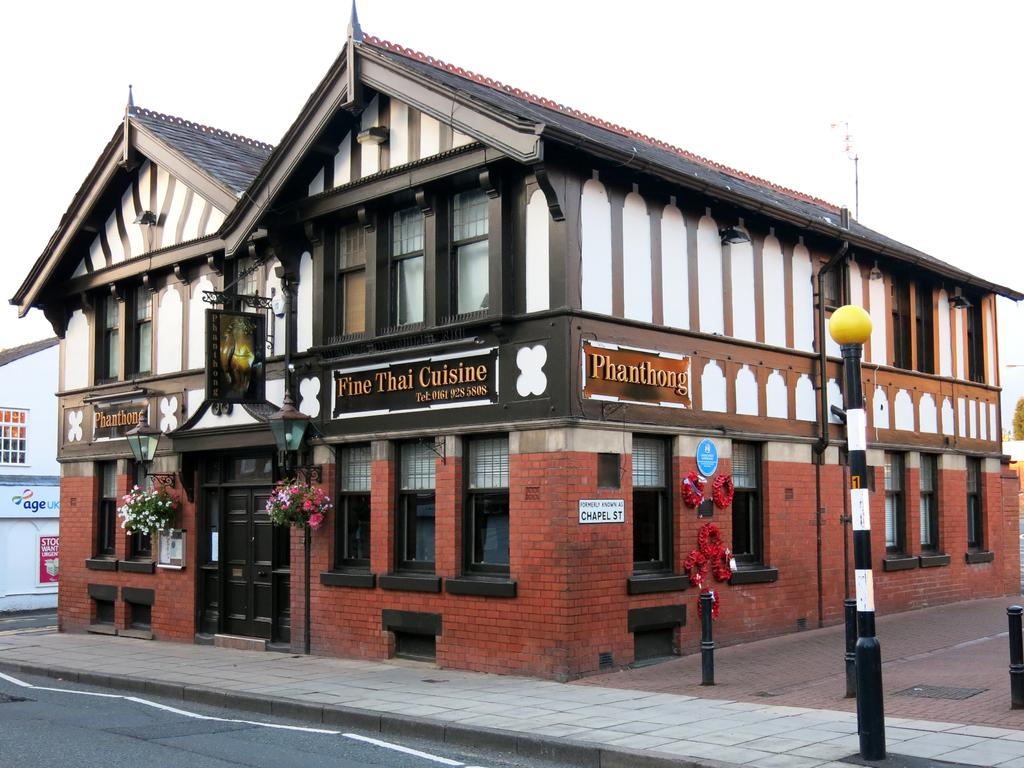What is the shape of the restaurant in the image? The restaurant is hat-shaped. Where is the restaurant located in relation to the road? The restaurant is beside the road. What material is used to construct the restaurant? The restaurant is made of brick walls. Does the restaurant have any openings for light and visibility? Yes, the restaurant has windows. What color is the door of the restaurant? There is a brown door in the image. What decorative items are present in front of the door? Flower pots are present in front of the door. What structures are visible in front of the restaurant? Poles and lights are visible in front of the restaurant. Can you tell me how many mountains are visible in the image? There are no mountains visible in the image; it features a hat-shaped restaurant beside the road. What type of digestive system does the restaurant have? The restaurant is not a living organism and therefore does not have a digestive system. 